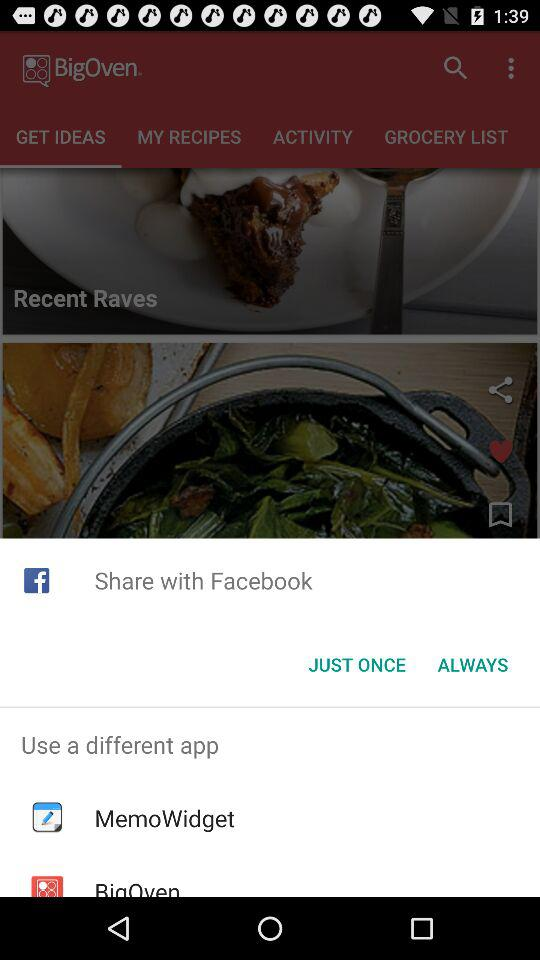What are the different applications to use? The different application is "MemoWidget". 